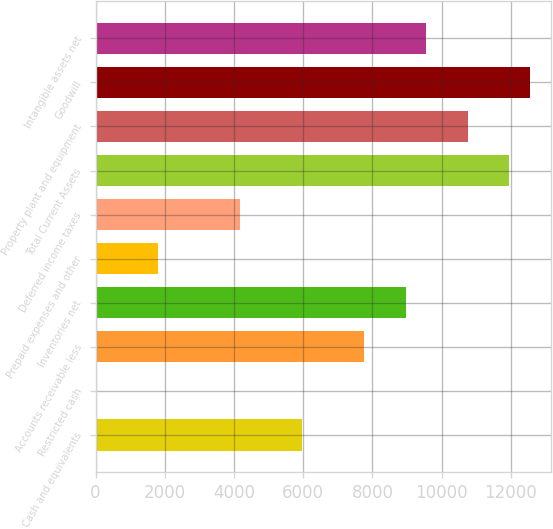Convert chart. <chart><loc_0><loc_0><loc_500><loc_500><bar_chart><fcel>Cash and equivalents<fcel>Restricted cash<fcel>Accounts receivable less<fcel>Inventories net<fcel>Prepaid expenses and other<fcel>Deferred income taxes<fcel>Total Current Assets<fcel>Property plant and equipment<fcel>Goodwill<fcel>Intangible assets net<nl><fcel>5974.4<fcel>2.4<fcel>7766<fcel>8960.4<fcel>1794<fcel>4182.8<fcel>11946.4<fcel>10752<fcel>12543.6<fcel>9557.6<nl></chart> 